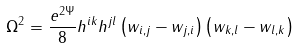Convert formula to latex. <formula><loc_0><loc_0><loc_500><loc_500>\Omega ^ { 2 } = \frac { e ^ { 2 \Psi } } { 8 } h ^ { i k } h ^ { j l } \left ( w _ { i , j } - w _ { j , i } \right ) \left ( w _ { k , l } - w _ { l , k } \right )</formula> 